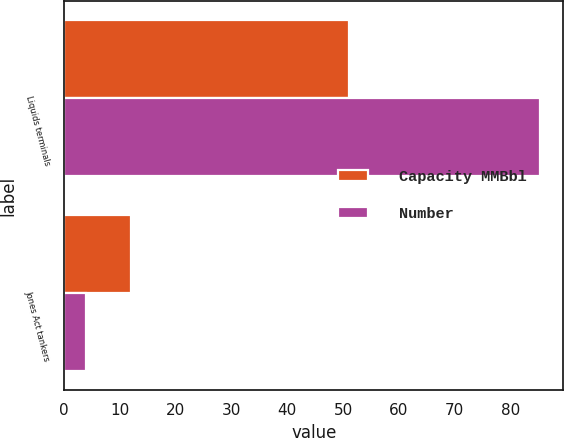Convert chart. <chart><loc_0><loc_0><loc_500><loc_500><stacked_bar_chart><ecel><fcel>Liquids terminals<fcel>Jones Act tankers<nl><fcel>Capacity MMBbl<fcel>51<fcel>12<nl><fcel>Number<fcel>85.2<fcel>4<nl></chart> 